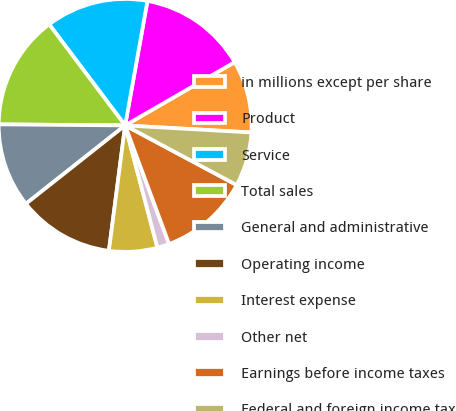Convert chart. <chart><loc_0><loc_0><loc_500><loc_500><pie_chart><fcel>in millions except per share<fcel>Product<fcel>Service<fcel>Total sales<fcel>General and administrative<fcel>Operating income<fcel>Interest expense<fcel>Other net<fcel>Earnings before income taxes<fcel>Federal and foreign income tax<nl><fcel>9.23%<fcel>13.84%<fcel>13.08%<fcel>14.61%<fcel>10.77%<fcel>12.31%<fcel>6.16%<fcel>1.54%<fcel>11.54%<fcel>6.92%<nl></chart> 